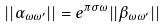Convert formula to latex. <formula><loc_0><loc_0><loc_500><loc_500>| | \alpha _ { \omega \omega ^ { \prime } } | | = e ^ { \pi \sigma \omega } | | \beta _ { \omega \omega ^ { \prime } } | |</formula> 